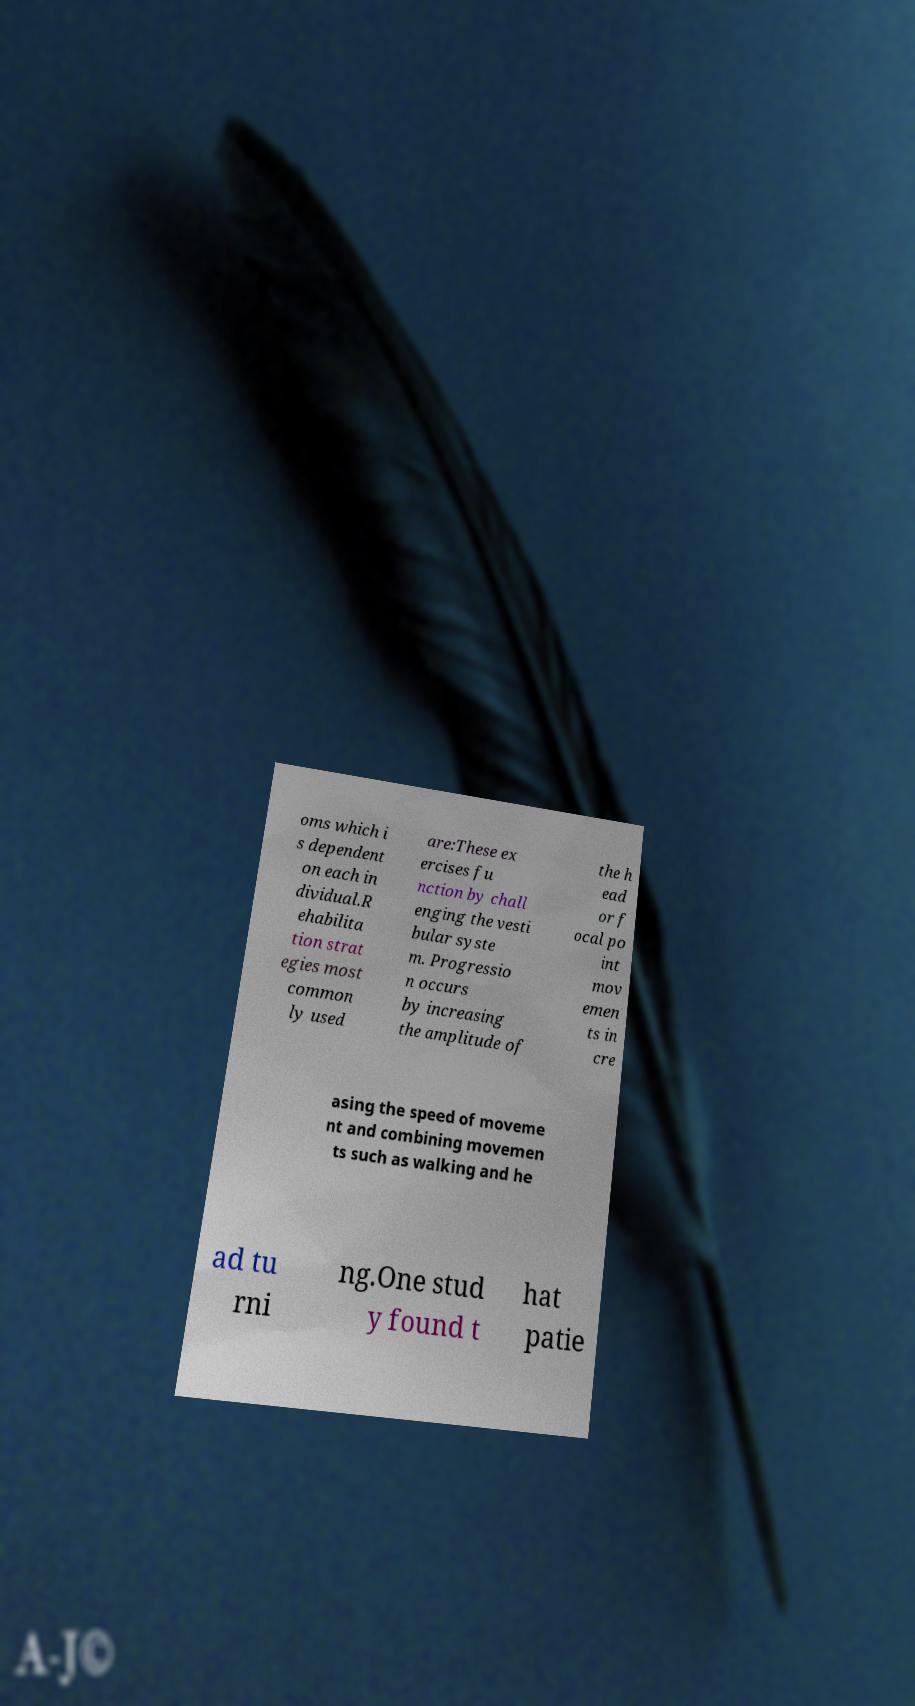Please identify and transcribe the text found in this image. oms which i s dependent on each in dividual.R ehabilita tion strat egies most common ly used are:These ex ercises fu nction by chall enging the vesti bular syste m. Progressio n occurs by increasing the amplitude of the h ead or f ocal po int mov emen ts in cre asing the speed of moveme nt and combining movemen ts such as walking and he ad tu rni ng.One stud y found t hat patie 